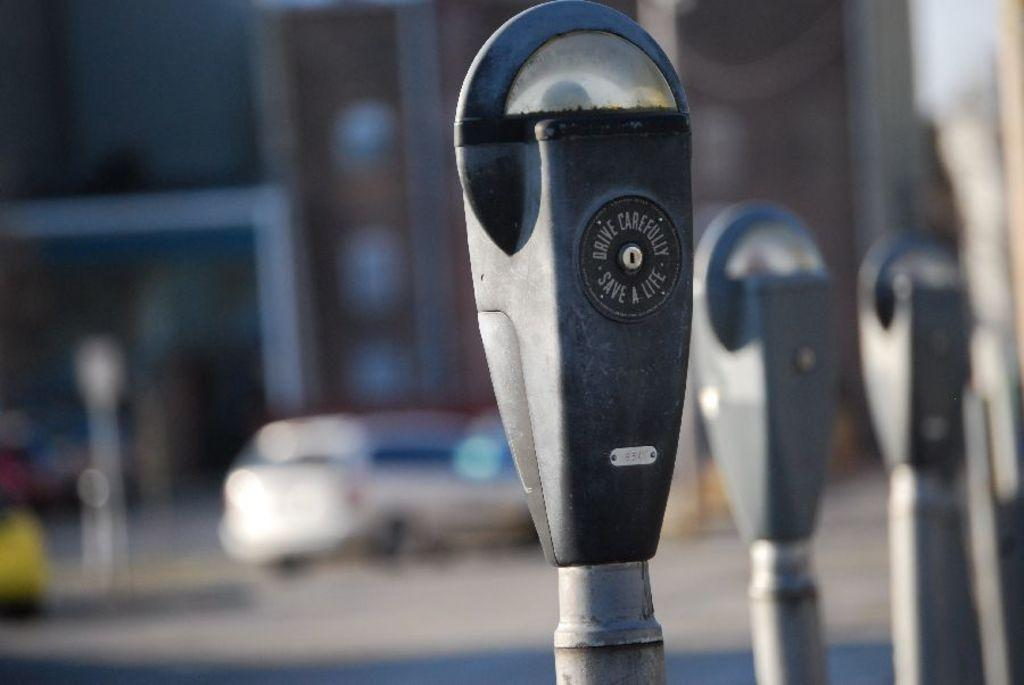<image>
Create a compact narrative representing the image presented. a parking meter outside with the word save on it 